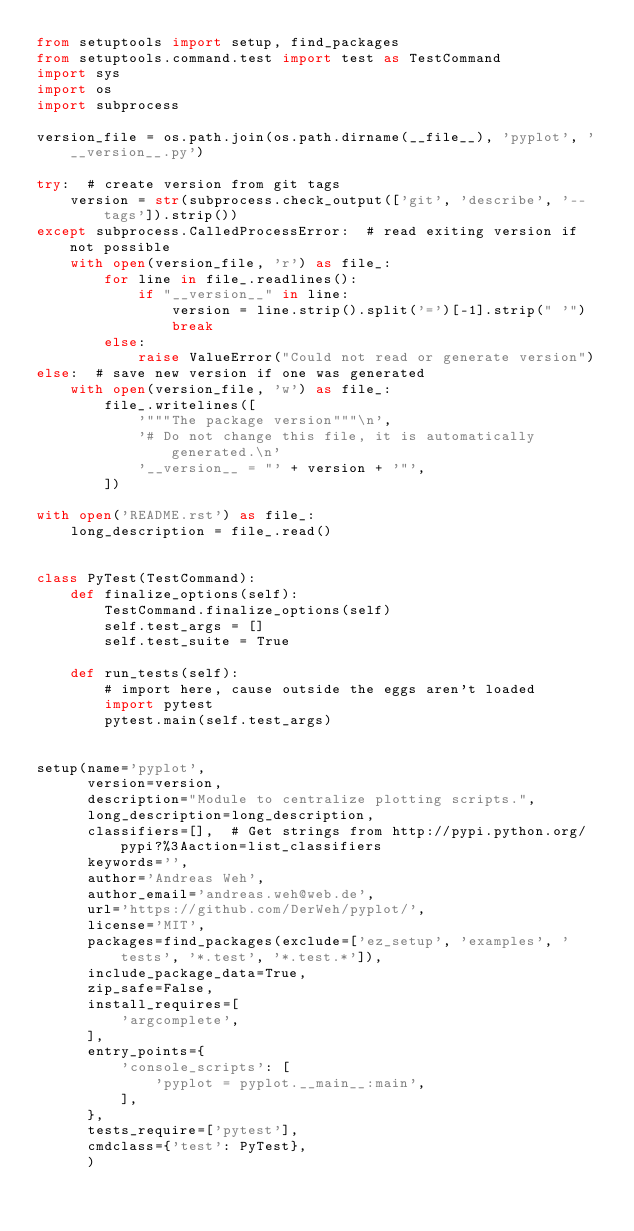<code> <loc_0><loc_0><loc_500><loc_500><_Python_>from setuptools import setup, find_packages
from setuptools.command.test import test as TestCommand
import sys
import os
import subprocess

version_file = os.path.join(os.path.dirname(__file__), 'pyplot', '__version__.py')

try:  # create version from git tags
    version = str(subprocess.check_output(['git', 'describe', '--tags']).strip())
except subprocess.CalledProcessError:  # read exiting version if not possible
    with open(version_file, 'r') as file_:
        for line in file_.readlines():
            if "__version__" in line:
                version = line.strip().split('=')[-1].strip(" '")
                break
        else:
            raise ValueError("Could not read or generate version")
else:  # save new version if one was generated
    with open(version_file, 'w') as file_:
        file_.writelines([
            '"""The package version"""\n',
            '# Do not change this file, it is automatically generated.\n'
            '__version__ = "' + version + '"',
        ])

with open('README.rst') as file_:
    long_description = file_.read()


class PyTest(TestCommand):
    def finalize_options(self):
        TestCommand.finalize_options(self)
        self.test_args = []
        self.test_suite = True

    def run_tests(self):
        # import here, cause outside the eggs aren't loaded
        import pytest
        pytest.main(self.test_args)


setup(name='pyplot',
      version=version,
      description="Module to centralize plotting scripts.",
      long_description=long_description,
      classifiers=[],  # Get strings from http://pypi.python.org/pypi?%3Aaction=list_classifiers
      keywords='',
      author='Andreas Weh',
      author_email='andreas.weh@web.de',
      url='https://github.com/DerWeh/pyplot/',
      license='MIT',
      packages=find_packages(exclude=['ez_setup', 'examples', 'tests', '*.test', '*.test.*']),
      include_package_data=True,
      zip_safe=False,
      install_requires=[
          'argcomplete',
      ],
      entry_points={
          'console_scripts': [
              'pyplot = pyplot.__main__:main',
          ],
      },
      tests_require=['pytest'],
      cmdclass={'test': PyTest},
      )
</code> 